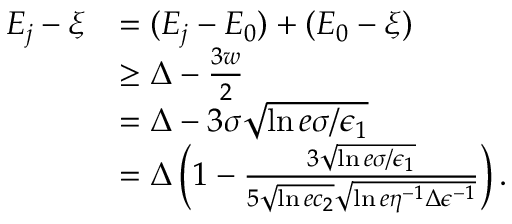Convert formula to latex. <formula><loc_0><loc_0><loc_500><loc_500>\begin{array} { r l } { E _ { j } - \xi } & { = ( E _ { j } - E _ { 0 } ) + ( E _ { 0 } - \xi ) } \\ & { \geq \Delta - \frac { 3 w } { 2 } } \\ & { = \Delta - 3 \sigma \sqrt { \ln { e \sigma / \epsilon _ { 1 } } } } \\ & { = \Delta \left ( 1 - \frac { 3 \sqrt { \ln { e \sigma / \epsilon _ { 1 } } } } { 5 \sqrt { \ln { e c _ { 2 } } } \sqrt { \ln { e \eta ^ { - 1 } \Delta \epsilon ^ { - 1 } } } } \right ) . } \end{array}</formula> 